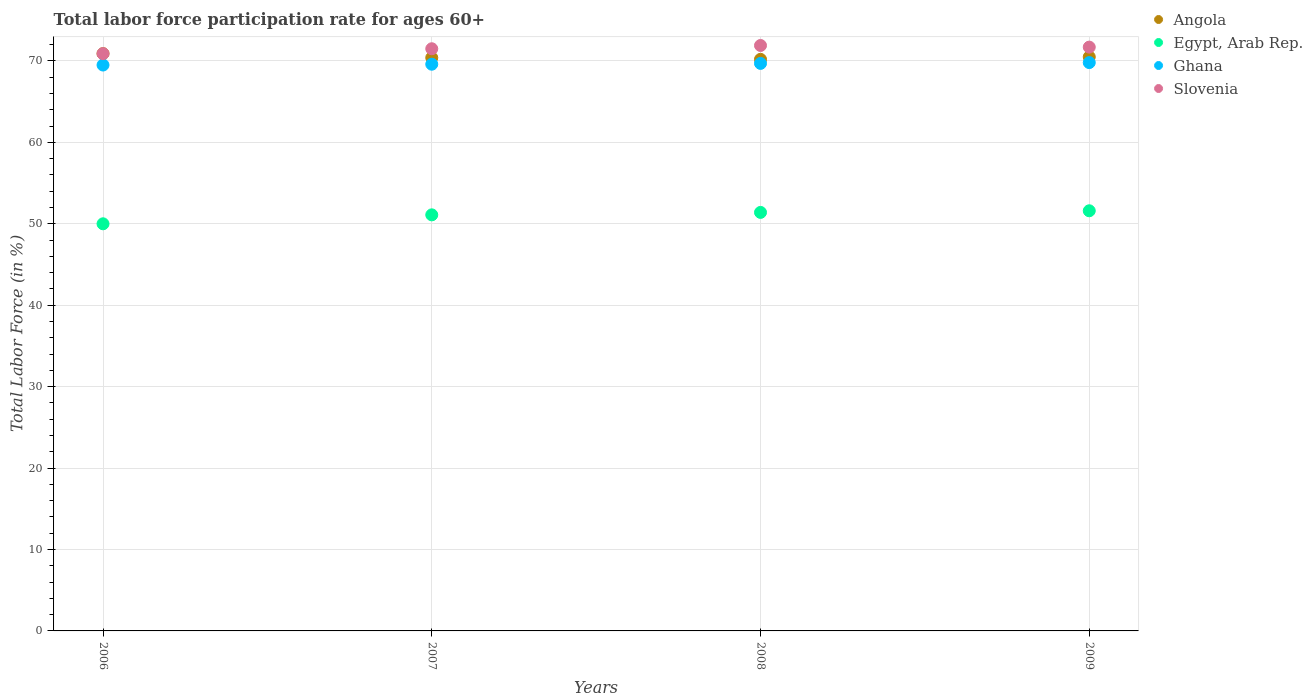Is the number of dotlines equal to the number of legend labels?
Provide a short and direct response. Yes. What is the labor force participation rate in Angola in 2009?
Your answer should be compact. 70.5. Across all years, what is the maximum labor force participation rate in Angola?
Give a very brief answer. 70.9. Across all years, what is the minimum labor force participation rate in Slovenia?
Provide a succinct answer. 70.9. In which year was the labor force participation rate in Angola maximum?
Give a very brief answer. 2006. In which year was the labor force participation rate in Angola minimum?
Your response must be concise. 2008. What is the total labor force participation rate in Slovenia in the graph?
Provide a short and direct response. 286. What is the difference between the labor force participation rate in Ghana in 2007 and that in 2009?
Your response must be concise. -0.2. What is the difference between the labor force participation rate in Egypt, Arab Rep. in 2006 and the labor force participation rate in Ghana in 2008?
Make the answer very short. -19.7. What is the average labor force participation rate in Angola per year?
Provide a succinct answer. 70.5. In the year 2008, what is the difference between the labor force participation rate in Slovenia and labor force participation rate in Angola?
Ensure brevity in your answer.  1.7. What is the ratio of the labor force participation rate in Egypt, Arab Rep. in 2006 to that in 2009?
Give a very brief answer. 0.97. Is the labor force participation rate in Egypt, Arab Rep. in 2008 less than that in 2009?
Give a very brief answer. Yes. Is the difference between the labor force participation rate in Slovenia in 2006 and 2007 greater than the difference between the labor force participation rate in Angola in 2006 and 2007?
Provide a short and direct response. No. What is the difference between the highest and the second highest labor force participation rate in Egypt, Arab Rep.?
Offer a terse response. 0.2. What is the difference between the highest and the lowest labor force participation rate in Ghana?
Keep it short and to the point. 0.3. Is it the case that in every year, the sum of the labor force participation rate in Egypt, Arab Rep. and labor force participation rate in Slovenia  is greater than the sum of labor force participation rate in Angola and labor force participation rate in Ghana?
Give a very brief answer. No. Is it the case that in every year, the sum of the labor force participation rate in Egypt, Arab Rep. and labor force participation rate in Slovenia  is greater than the labor force participation rate in Angola?
Offer a very short reply. Yes. Is the labor force participation rate in Angola strictly greater than the labor force participation rate in Slovenia over the years?
Provide a short and direct response. No. Is the labor force participation rate in Ghana strictly less than the labor force participation rate in Egypt, Arab Rep. over the years?
Provide a succinct answer. No. How many dotlines are there?
Offer a terse response. 4. How many years are there in the graph?
Provide a short and direct response. 4. What is the difference between two consecutive major ticks on the Y-axis?
Offer a terse response. 10. Are the values on the major ticks of Y-axis written in scientific E-notation?
Your response must be concise. No. Does the graph contain any zero values?
Provide a succinct answer. No. Does the graph contain grids?
Provide a succinct answer. Yes. How are the legend labels stacked?
Your answer should be compact. Vertical. What is the title of the graph?
Keep it short and to the point. Total labor force participation rate for ages 60+. Does "Liberia" appear as one of the legend labels in the graph?
Your answer should be compact. No. What is the label or title of the X-axis?
Provide a short and direct response. Years. What is the Total Labor Force (in %) of Angola in 2006?
Offer a terse response. 70.9. What is the Total Labor Force (in %) of Ghana in 2006?
Offer a very short reply. 69.5. What is the Total Labor Force (in %) in Slovenia in 2006?
Your answer should be compact. 70.9. What is the Total Labor Force (in %) in Angola in 2007?
Your answer should be compact. 70.4. What is the Total Labor Force (in %) of Egypt, Arab Rep. in 2007?
Make the answer very short. 51.1. What is the Total Labor Force (in %) in Ghana in 2007?
Your answer should be very brief. 69.6. What is the Total Labor Force (in %) of Slovenia in 2007?
Provide a succinct answer. 71.5. What is the Total Labor Force (in %) of Angola in 2008?
Ensure brevity in your answer.  70.2. What is the Total Labor Force (in %) in Egypt, Arab Rep. in 2008?
Provide a short and direct response. 51.4. What is the Total Labor Force (in %) in Ghana in 2008?
Offer a terse response. 69.7. What is the Total Labor Force (in %) in Slovenia in 2008?
Your answer should be very brief. 71.9. What is the Total Labor Force (in %) of Angola in 2009?
Your answer should be compact. 70.5. What is the Total Labor Force (in %) in Egypt, Arab Rep. in 2009?
Offer a terse response. 51.6. What is the Total Labor Force (in %) in Ghana in 2009?
Offer a very short reply. 69.8. What is the Total Labor Force (in %) in Slovenia in 2009?
Give a very brief answer. 71.7. Across all years, what is the maximum Total Labor Force (in %) in Angola?
Make the answer very short. 70.9. Across all years, what is the maximum Total Labor Force (in %) of Egypt, Arab Rep.?
Offer a terse response. 51.6. Across all years, what is the maximum Total Labor Force (in %) in Ghana?
Your response must be concise. 69.8. Across all years, what is the maximum Total Labor Force (in %) in Slovenia?
Give a very brief answer. 71.9. Across all years, what is the minimum Total Labor Force (in %) in Angola?
Make the answer very short. 70.2. Across all years, what is the minimum Total Labor Force (in %) of Ghana?
Provide a short and direct response. 69.5. Across all years, what is the minimum Total Labor Force (in %) in Slovenia?
Your answer should be very brief. 70.9. What is the total Total Labor Force (in %) of Angola in the graph?
Provide a short and direct response. 282. What is the total Total Labor Force (in %) of Egypt, Arab Rep. in the graph?
Offer a terse response. 204.1. What is the total Total Labor Force (in %) of Ghana in the graph?
Offer a terse response. 278.6. What is the total Total Labor Force (in %) in Slovenia in the graph?
Your response must be concise. 286. What is the difference between the Total Labor Force (in %) in Angola in 2006 and that in 2007?
Give a very brief answer. 0.5. What is the difference between the Total Labor Force (in %) in Egypt, Arab Rep. in 2006 and that in 2007?
Provide a short and direct response. -1.1. What is the difference between the Total Labor Force (in %) of Angola in 2006 and that in 2008?
Provide a short and direct response. 0.7. What is the difference between the Total Labor Force (in %) of Ghana in 2006 and that in 2008?
Your response must be concise. -0.2. What is the difference between the Total Labor Force (in %) in Slovenia in 2006 and that in 2009?
Keep it short and to the point. -0.8. What is the difference between the Total Labor Force (in %) of Angola in 2007 and that in 2008?
Offer a very short reply. 0.2. What is the difference between the Total Labor Force (in %) in Ghana in 2007 and that in 2009?
Provide a short and direct response. -0.2. What is the difference between the Total Labor Force (in %) of Slovenia in 2007 and that in 2009?
Provide a succinct answer. -0.2. What is the difference between the Total Labor Force (in %) in Ghana in 2008 and that in 2009?
Keep it short and to the point. -0.1. What is the difference between the Total Labor Force (in %) of Slovenia in 2008 and that in 2009?
Ensure brevity in your answer.  0.2. What is the difference between the Total Labor Force (in %) in Angola in 2006 and the Total Labor Force (in %) in Egypt, Arab Rep. in 2007?
Provide a succinct answer. 19.8. What is the difference between the Total Labor Force (in %) in Egypt, Arab Rep. in 2006 and the Total Labor Force (in %) in Ghana in 2007?
Make the answer very short. -19.6. What is the difference between the Total Labor Force (in %) of Egypt, Arab Rep. in 2006 and the Total Labor Force (in %) of Slovenia in 2007?
Make the answer very short. -21.5. What is the difference between the Total Labor Force (in %) in Ghana in 2006 and the Total Labor Force (in %) in Slovenia in 2007?
Provide a succinct answer. -2. What is the difference between the Total Labor Force (in %) in Angola in 2006 and the Total Labor Force (in %) in Egypt, Arab Rep. in 2008?
Provide a short and direct response. 19.5. What is the difference between the Total Labor Force (in %) of Angola in 2006 and the Total Labor Force (in %) of Ghana in 2008?
Make the answer very short. 1.2. What is the difference between the Total Labor Force (in %) in Egypt, Arab Rep. in 2006 and the Total Labor Force (in %) in Ghana in 2008?
Give a very brief answer. -19.7. What is the difference between the Total Labor Force (in %) of Egypt, Arab Rep. in 2006 and the Total Labor Force (in %) of Slovenia in 2008?
Provide a succinct answer. -21.9. What is the difference between the Total Labor Force (in %) in Angola in 2006 and the Total Labor Force (in %) in Egypt, Arab Rep. in 2009?
Provide a succinct answer. 19.3. What is the difference between the Total Labor Force (in %) in Angola in 2006 and the Total Labor Force (in %) in Slovenia in 2009?
Offer a very short reply. -0.8. What is the difference between the Total Labor Force (in %) of Egypt, Arab Rep. in 2006 and the Total Labor Force (in %) of Ghana in 2009?
Give a very brief answer. -19.8. What is the difference between the Total Labor Force (in %) of Egypt, Arab Rep. in 2006 and the Total Labor Force (in %) of Slovenia in 2009?
Provide a succinct answer. -21.7. What is the difference between the Total Labor Force (in %) in Angola in 2007 and the Total Labor Force (in %) in Ghana in 2008?
Provide a succinct answer. 0.7. What is the difference between the Total Labor Force (in %) in Angola in 2007 and the Total Labor Force (in %) in Slovenia in 2008?
Provide a short and direct response. -1.5. What is the difference between the Total Labor Force (in %) in Egypt, Arab Rep. in 2007 and the Total Labor Force (in %) in Ghana in 2008?
Give a very brief answer. -18.6. What is the difference between the Total Labor Force (in %) of Egypt, Arab Rep. in 2007 and the Total Labor Force (in %) of Slovenia in 2008?
Make the answer very short. -20.8. What is the difference between the Total Labor Force (in %) of Angola in 2007 and the Total Labor Force (in %) of Egypt, Arab Rep. in 2009?
Your response must be concise. 18.8. What is the difference between the Total Labor Force (in %) in Angola in 2007 and the Total Labor Force (in %) in Slovenia in 2009?
Ensure brevity in your answer.  -1.3. What is the difference between the Total Labor Force (in %) in Egypt, Arab Rep. in 2007 and the Total Labor Force (in %) in Ghana in 2009?
Your answer should be very brief. -18.7. What is the difference between the Total Labor Force (in %) in Egypt, Arab Rep. in 2007 and the Total Labor Force (in %) in Slovenia in 2009?
Provide a short and direct response. -20.6. What is the difference between the Total Labor Force (in %) of Ghana in 2007 and the Total Labor Force (in %) of Slovenia in 2009?
Your answer should be very brief. -2.1. What is the difference between the Total Labor Force (in %) of Angola in 2008 and the Total Labor Force (in %) of Ghana in 2009?
Ensure brevity in your answer.  0.4. What is the difference between the Total Labor Force (in %) in Egypt, Arab Rep. in 2008 and the Total Labor Force (in %) in Ghana in 2009?
Your answer should be very brief. -18.4. What is the difference between the Total Labor Force (in %) in Egypt, Arab Rep. in 2008 and the Total Labor Force (in %) in Slovenia in 2009?
Your response must be concise. -20.3. What is the average Total Labor Force (in %) of Angola per year?
Your answer should be compact. 70.5. What is the average Total Labor Force (in %) in Egypt, Arab Rep. per year?
Your answer should be very brief. 51.02. What is the average Total Labor Force (in %) of Ghana per year?
Offer a terse response. 69.65. What is the average Total Labor Force (in %) in Slovenia per year?
Keep it short and to the point. 71.5. In the year 2006, what is the difference between the Total Labor Force (in %) in Angola and Total Labor Force (in %) in Egypt, Arab Rep.?
Your response must be concise. 20.9. In the year 2006, what is the difference between the Total Labor Force (in %) in Angola and Total Labor Force (in %) in Ghana?
Offer a terse response. 1.4. In the year 2006, what is the difference between the Total Labor Force (in %) of Egypt, Arab Rep. and Total Labor Force (in %) of Ghana?
Your answer should be very brief. -19.5. In the year 2006, what is the difference between the Total Labor Force (in %) in Egypt, Arab Rep. and Total Labor Force (in %) in Slovenia?
Your response must be concise. -20.9. In the year 2007, what is the difference between the Total Labor Force (in %) in Angola and Total Labor Force (in %) in Egypt, Arab Rep.?
Your answer should be very brief. 19.3. In the year 2007, what is the difference between the Total Labor Force (in %) in Angola and Total Labor Force (in %) in Slovenia?
Ensure brevity in your answer.  -1.1. In the year 2007, what is the difference between the Total Labor Force (in %) in Egypt, Arab Rep. and Total Labor Force (in %) in Ghana?
Offer a very short reply. -18.5. In the year 2007, what is the difference between the Total Labor Force (in %) of Egypt, Arab Rep. and Total Labor Force (in %) of Slovenia?
Your answer should be very brief. -20.4. In the year 2008, what is the difference between the Total Labor Force (in %) of Angola and Total Labor Force (in %) of Ghana?
Provide a short and direct response. 0.5. In the year 2008, what is the difference between the Total Labor Force (in %) of Angola and Total Labor Force (in %) of Slovenia?
Make the answer very short. -1.7. In the year 2008, what is the difference between the Total Labor Force (in %) of Egypt, Arab Rep. and Total Labor Force (in %) of Ghana?
Your answer should be very brief. -18.3. In the year 2008, what is the difference between the Total Labor Force (in %) of Egypt, Arab Rep. and Total Labor Force (in %) of Slovenia?
Your answer should be compact. -20.5. In the year 2009, what is the difference between the Total Labor Force (in %) in Egypt, Arab Rep. and Total Labor Force (in %) in Ghana?
Your response must be concise. -18.2. In the year 2009, what is the difference between the Total Labor Force (in %) in Egypt, Arab Rep. and Total Labor Force (in %) in Slovenia?
Your answer should be compact. -20.1. What is the ratio of the Total Labor Force (in %) of Angola in 2006 to that in 2007?
Keep it short and to the point. 1.01. What is the ratio of the Total Labor Force (in %) in Egypt, Arab Rep. in 2006 to that in 2007?
Keep it short and to the point. 0.98. What is the ratio of the Total Labor Force (in %) in Slovenia in 2006 to that in 2007?
Provide a short and direct response. 0.99. What is the ratio of the Total Labor Force (in %) in Egypt, Arab Rep. in 2006 to that in 2008?
Your answer should be very brief. 0.97. What is the ratio of the Total Labor Force (in %) in Ghana in 2006 to that in 2008?
Your answer should be very brief. 1. What is the ratio of the Total Labor Force (in %) in Slovenia in 2006 to that in 2008?
Your answer should be compact. 0.99. What is the ratio of the Total Labor Force (in %) in Egypt, Arab Rep. in 2006 to that in 2009?
Your answer should be compact. 0.97. What is the ratio of the Total Labor Force (in %) in Ghana in 2006 to that in 2009?
Your answer should be compact. 1. What is the ratio of the Total Labor Force (in %) of Slovenia in 2006 to that in 2009?
Your answer should be compact. 0.99. What is the ratio of the Total Labor Force (in %) of Ghana in 2007 to that in 2008?
Make the answer very short. 1. What is the ratio of the Total Labor Force (in %) in Egypt, Arab Rep. in 2007 to that in 2009?
Give a very brief answer. 0.99. What is the ratio of the Total Labor Force (in %) in Angola in 2008 to that in 2009?
Your answer should be very brief. 1. What is the ratio of the Total Labor Force (in %) of Egypt, Arab Rep. in 2008 to that in 2009?
Offer a terse response. 1. What is the difference between the highest and the lowest Total Labor Force (in %) of Egypt, Arab Rep.?
Keep it short and to the point. 1.6. What is the difference between the highest and the lowest Total Labor Force (in %) in Slovenia?
Give a very brief answer. 1. 